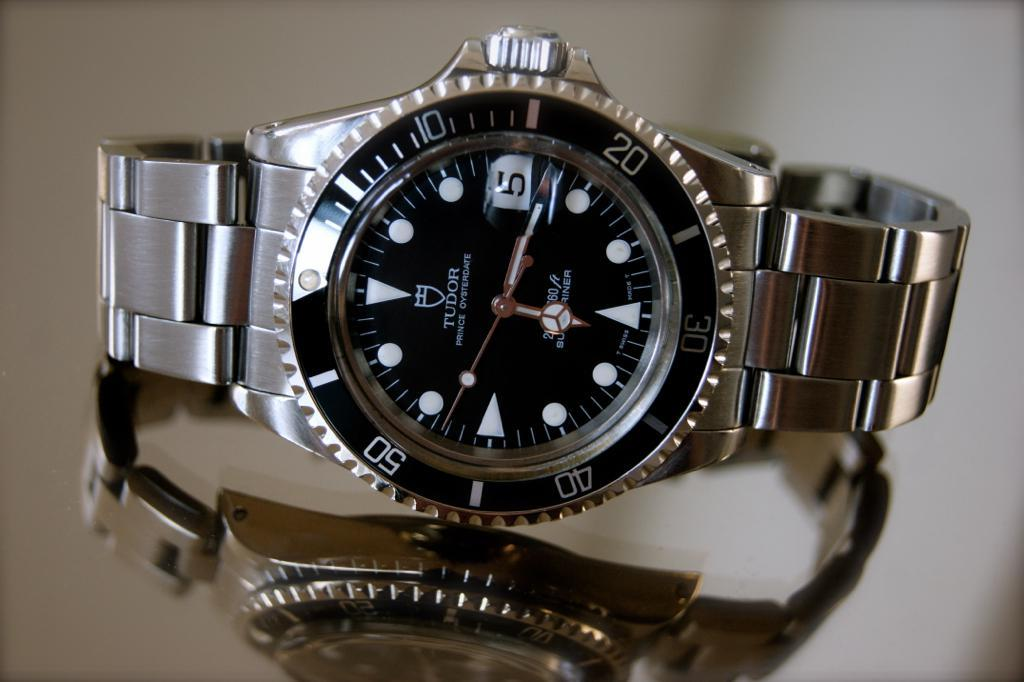<image>
Summarize the visual content of the image. Silver and black wrist watch that says TUDOR on the face. 